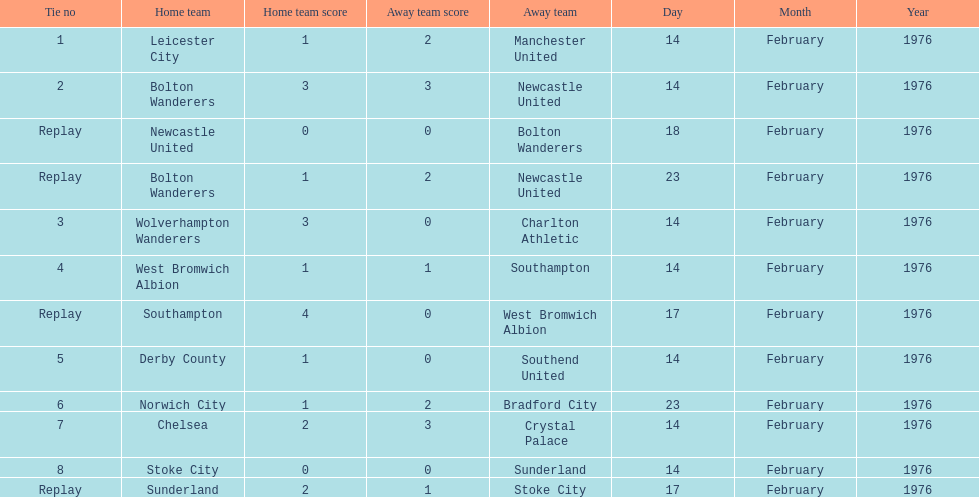Give me the full table as a dictionary. {'header': ['Tie no', 'Home team', 'Home team score', 'Away team score', 'Away team', 'Day', 'Month', 'Year'], 'rows': [['1', 'Leicester City', '1', '2', 'Manchester United', '14', 'February', '1976'], ['2', 'Bolton Wanderers', '3', '3', 'Newcastle United', '14', 'February', '1976'], ['Replay', 'Newcastle United', '0', '0', 'Bolton Wanderers', '18', 'February', '1976'], ['Replay', 'Bolton Wanderers', '1', '2', 'Newcastle United', '23', 'February', '1976'], ['3', 'Wolverhampton Wanderers', '3', '0', 'Charlton Athletic', '14', 'February', '1976'], ['4', 'West Bromwich Albion', '1', '1', 'Southampton', '14', 'February', '1976'], ['Replay', 'Southampton', '4', '0', 'West Bromwich Albion', '17', 'February', '1976'], ['5', 'Derby County', '1', '0', 'Southend United', '14', 'February', '1976'], ['6', 'Norwich City', '1', '2', 'Bradford City', '23', 'February', '1976'], ['7', 'Chelsea', '2', '3', 'Crystal Palace', '14', 'February', '1976'], ['8', 'Stoke City', '0', '0', 'Sunderland', '14', 'February', '1976'], ['Replay', 'Sunderland', '2', '1', 'Stoke City', '17', 'February', '1976']]} How many games were replays? 4. 